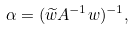Convert formula to latex. <formula><loc_0><loc_0><loc_500><loc_500>\alpha = ( { \widetilde { w } A ^ { - 1 } w } ) ^ { - 1 } ,</formula> 